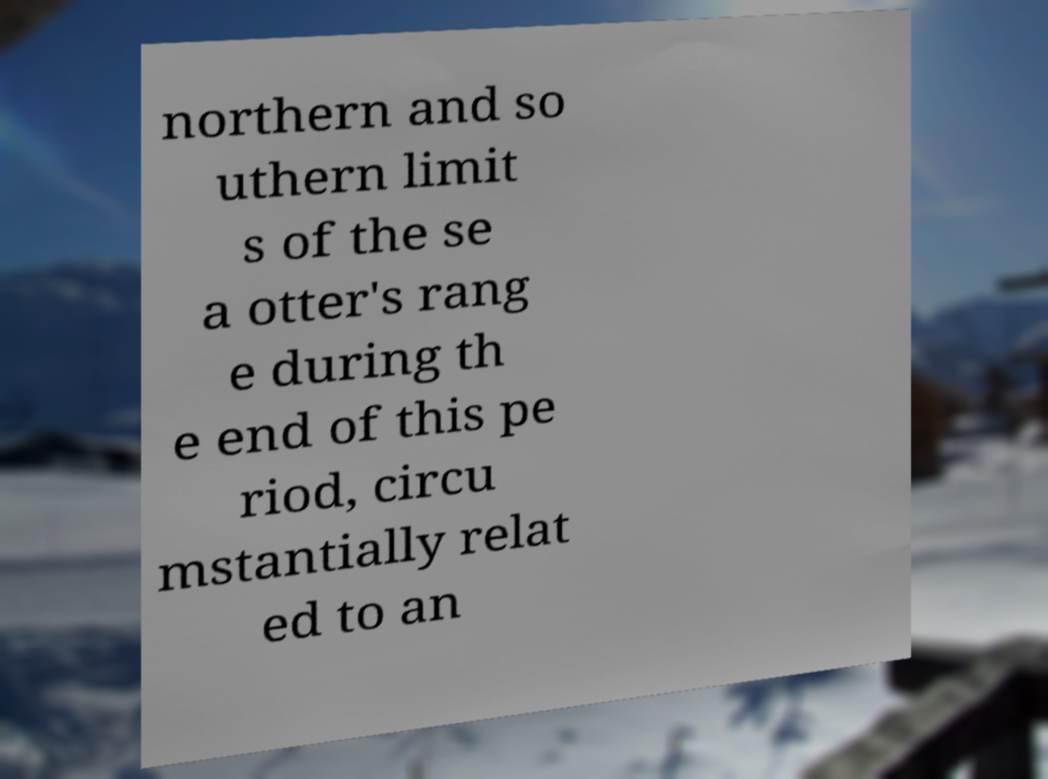For documentation purposes, I need the text within this image transcribed. Could you provide that? northern and so uthern limit s of the se a otter's rang e during th e end of this pe riod, circu mstantially relat ed to an 